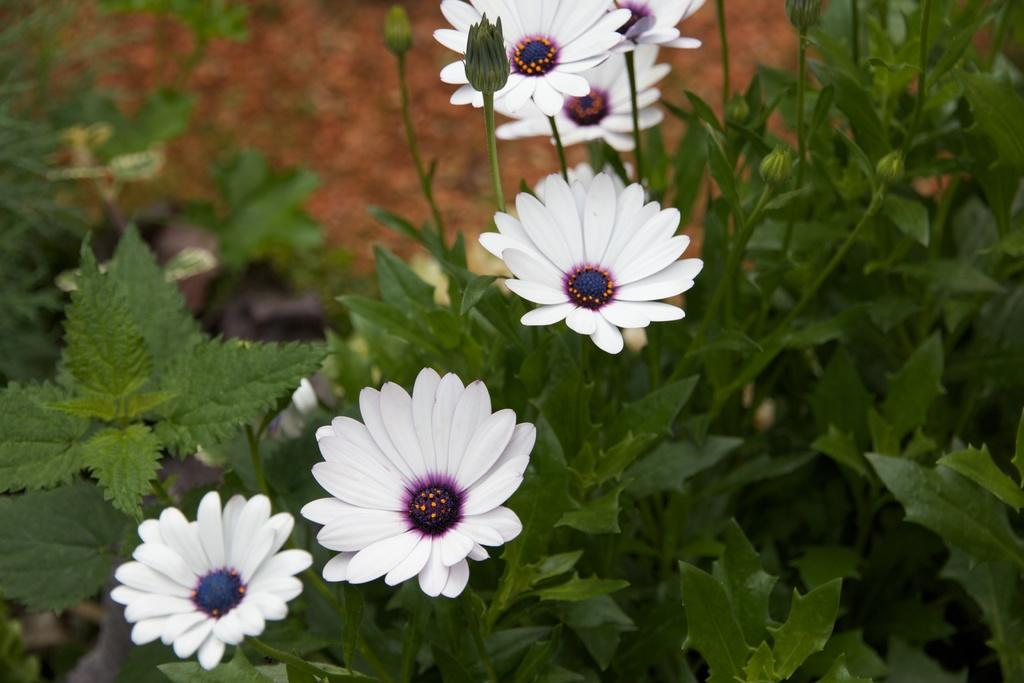What type of flowers can be seen in the image? There are white color flowers in the image. What parts of the flowers are visible? There are stems and leaves visible in the image. What type of ducks can be seen resting near the flowers in the image? There are no ducks present in the image. 